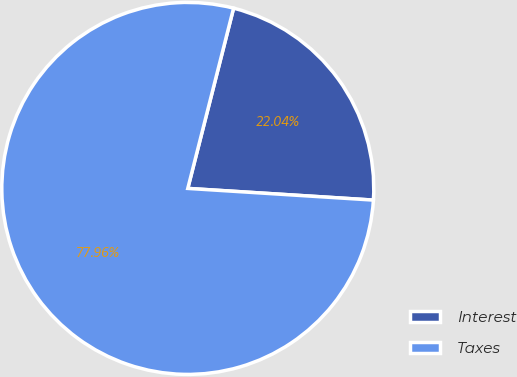<chart> <loc_0><loc_0><loc_500><loc_500><pie_chart><fcel>Interest<fcel>Taxes<nl><fcel>22.04%<fcel>77.96%<nl></chart> 